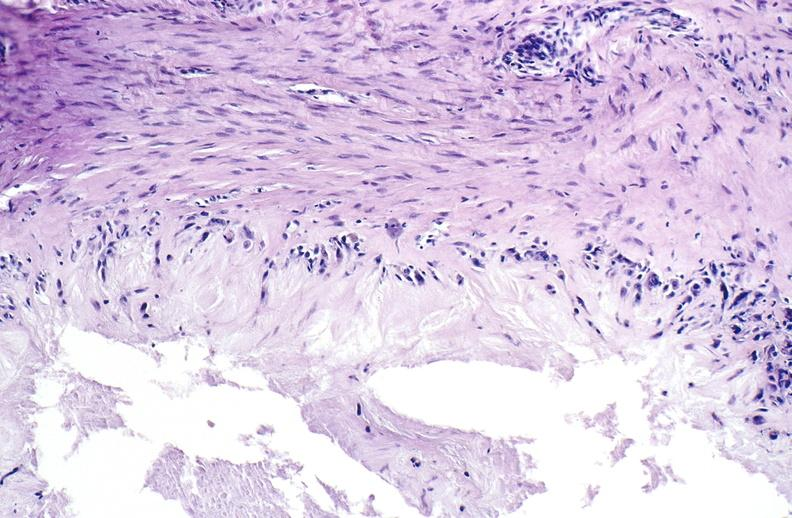s joints present?
Answer the question using a single word or phrase. Yes 